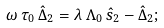Convert formula to latex. <formula><loc_0><loc_0><loc_500><loc_500>\omega \, \tau _ { 0 } \, \hat { \Delta } _ { 2 } = \lambda \, \Lambda _ { 0 } \, \hat { s } _ { 2 } - \hat { \Delta } _ { 2 } ;</formula> 